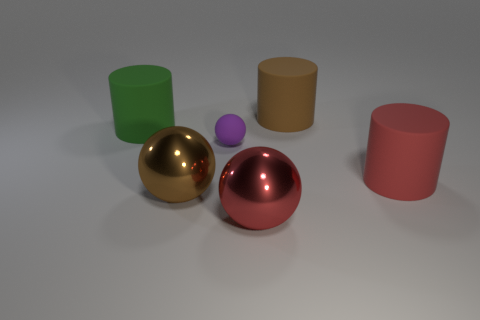The large red thing to the left of the large matte thing that is on the right side of the brown rubber thing is made of what material?
Make the answer very short. Metal. There is a thing behind the green matte cylinder; what material is it?
Provide a short and direct response. Rubber. What number of other big red objects have the same shape as the red matte thing?
Your answer should be very brief. 0. What material is the large green object that is in front of the rubber cylinder that is behind the rubber cylinder left of the big brown metal thing?
Your response must be concise. Rubber. Are there any purple matte spheres in front of the rubber sphere?
Give a very brief answer. No. There is a brown matte thing that is the same size as the green matte cylinder; what shape is it?
Provide a succinct answer. Cylinder. Does the brown ball have the same material as the purple object?
Offer a terse response. No. What number of matte things are big brown things or small green spheres?
Give a very brief answer. 1. There is a rubber cylinder in front of the small purple sphere; is its color the same as the tiny rubber ball?
Provide a succinct answer. No. What is the shape of the large brown thing that is in front of the big brown thing that is behind the large red rubber cylinder?
Keep it short and to the point. Sphere. 